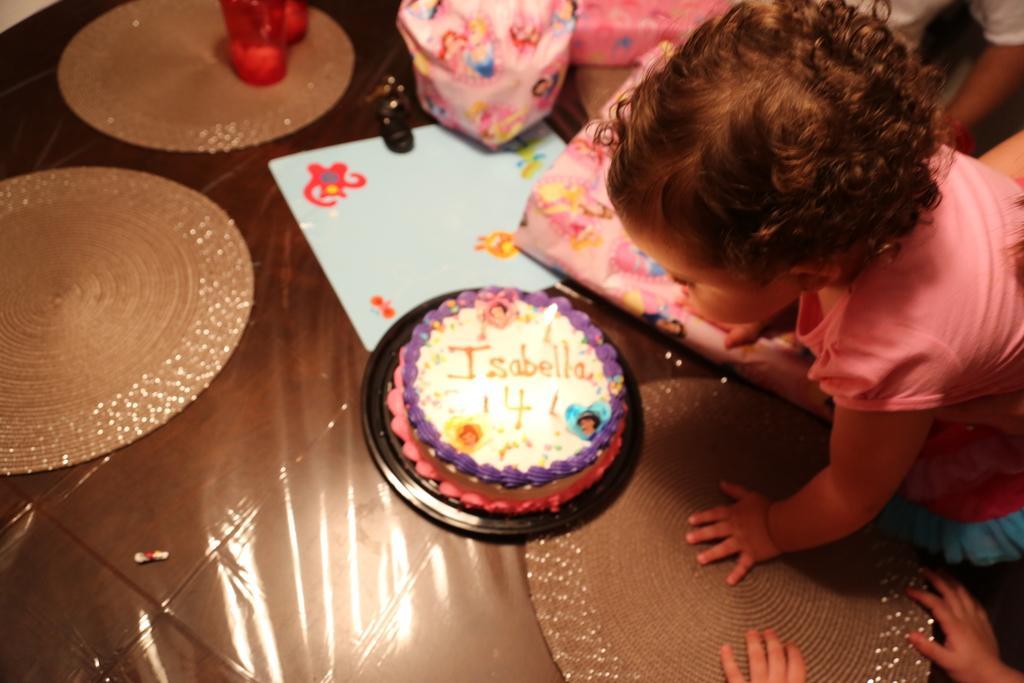Please provide a concise description of this image. In this image I can see a cake and some objects on the brown color floor. I can see a child wearing pink color dress and back I can see few people. 